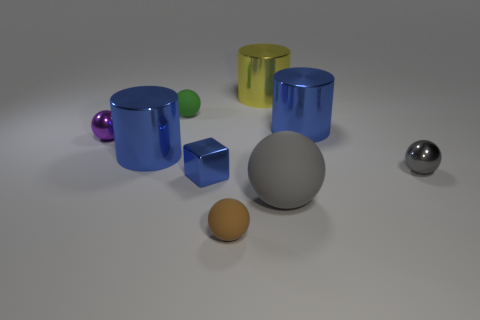Subtract 1 balls. How many balls are left? 4 Subtract all green spheres. How many spheres are left? 4 Subtract all brown spheres. How many spheres are left? 4 Subtract all cyan spheres. Subtract all cyan cylinders. How many spheres are left? 5 Add 1 brown things. How many objects exist? 10 Subtract all balls. How many objects are left? 4 Add 6 cylinders. How many cylinders are left? 9 Add 4 tiny cubes. How many tiny cubes exist? 5 Subtract 0 blue spheres. How many objects are left? 9 Subtract all small metallic blocks. Subtract all small brown metal cylinders. How many objects are left? 8 